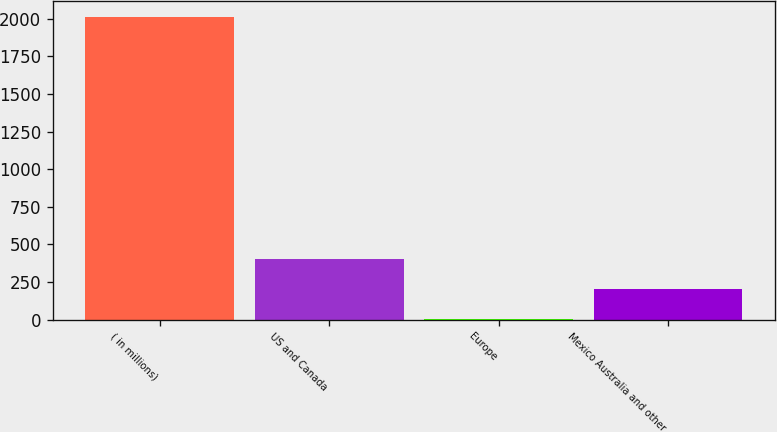<chart> <loc_0><loc_0><loc_500><loc_500><bar_chart><fcel>( in millions)<fcel>US and Canada<fcel>Europe<fcel>Mexico Australia and other<nl><fcel>2015<fcel>404.52<fcel>1.9<fcel>203.21<nl></chart> 